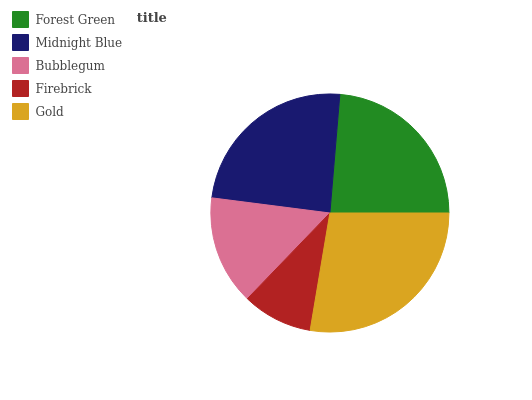Is Firebrick the minimum?
Answer yes or no. Yes. Is Gold the maximum?
Answer yes or no. Yes. Is Midnight Blue the minimum?
Answer yes or no. No. Is Midnight Blue the maximum?
Answer yes or no. No. Is Midnight Blue greater than Forest Green?
Answer yes or no. Yes. Is Forest Green less than Midnight Blue?
Answer yes or no. Yes. Is Forest Green greater than Midnight Blue?
Answer yes or no. No. Is Midnight Blue less than Forest Green?
Answer yes or no. No. Is Forest Green the high median?
Answer yes or no. Yes. Is Forest Green the low median?
Answer yes or no. Yes. Is Gold the high median?
Answer yes or no. No. Is Midnight Blue the low median?
Answer yes or no. No. 